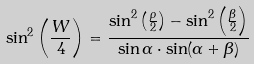<formula> <loc_0><loc_0><loc_500><loc_500>\sin ^ { 2 } \left ( \frac { W } { 4 } \right ) = \frac { \sin ^ { 2 } \left ( \frac { \rho } { 2 } \right ) - \sin ^ { 2 } \left ( \frac { \beta } { 2 } \right ) } { \sin \alpha \cdot \sin ( \alpha + \beta ) }</formula> 